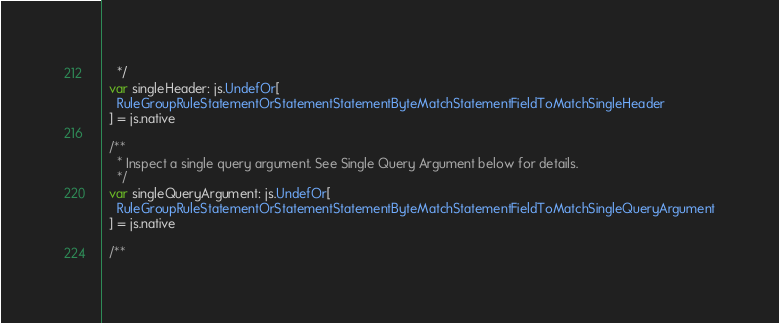<code> <loc_0><loc_0><loc_500><loc_500><_Scala_>    */
  var singleHeader: js.UndefOr[
    RuleGroupRuleStatementOrStatementStatementByteMatchStatementFieldToMatchSingleHeader
  ] = js.native
  
  /**
    * Inspect a single query argument. See Single Query Argument below for details.
    */
  var singleQueryArgument: js.UndefOr[
    RuleGroupRuleStatementOrStatementStatementByteMatchStatementFieldToMatchSingleQueryArgument
  ] = js.native
  
  /**</code> 